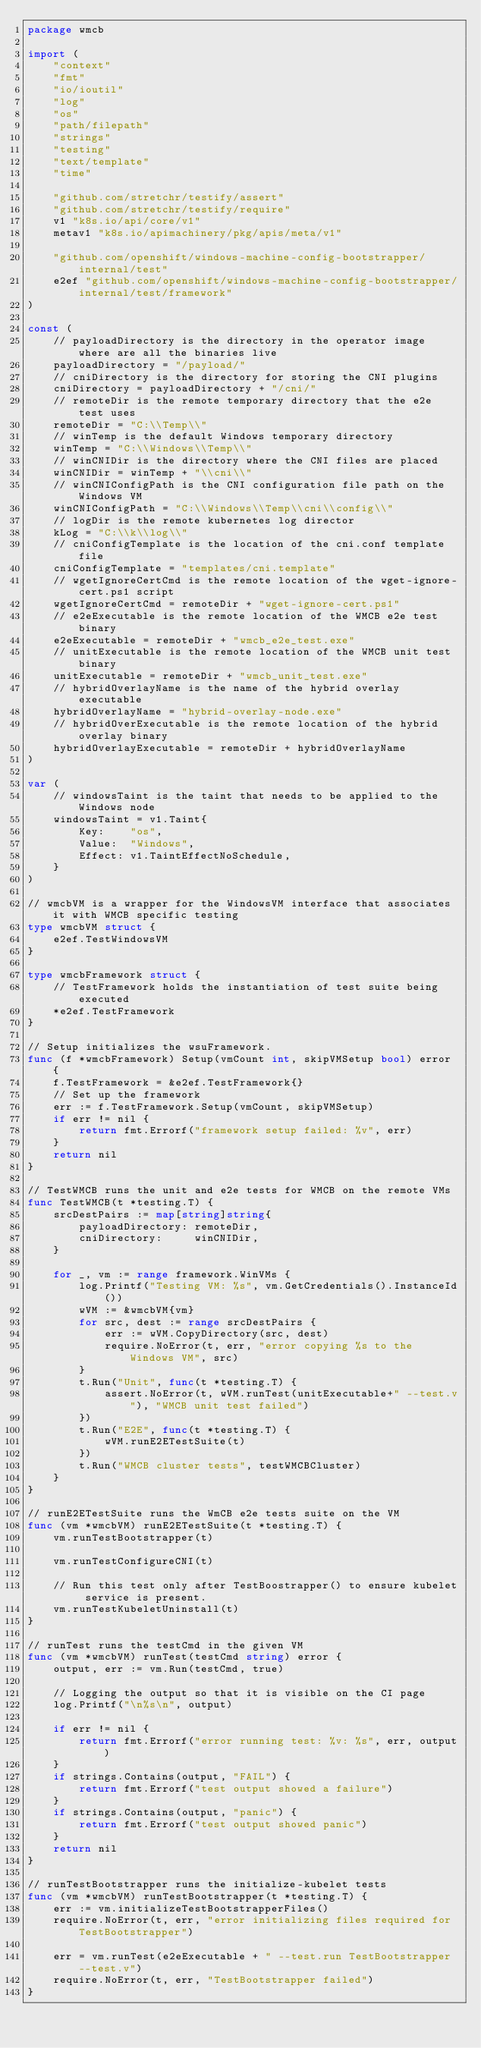<code> <loc_0><loc_0><loc_500><loc_500><_Go_>package wmcb

import (
	"context"
	"fmt"
	"io/ioutil"
	"log"
	"os"
	"path/filepath"
	"strings"
	"testing"
	"text/template"
	"time"

	"github.com/stretchr/testify/assert"
	"github.com/stretchr/testify/require"
	v1 "k8s.io/api/core/v1"
	metav1 "k8s.io/apimachinery/pkg/apis/meta/v1"

	"github.com/openshift/windows-machine-config-bootstrapper/internal/test"
	e2ef "github.com/openshift/windows-machine-config-bootstrapper/internal/test/framework"
)

const (
	// payloadDirectory is the directory in the operator image where are all the binaries live
	payloadDirectory = "/payload/"
	// cniDirectory is the directory for storing the CNI plugins
	cniDirectory = payloadDirectory + "/cni/"
	// remoteDir is the remote temporary directory that the e2e test uses
	remoteDir = "C:\\Temp\\"
	// winTemp is the default Windows temporary directory
	winTemp = "C:\\Windows\\Temp\\"
	// winCNIDir is the directory where the CNI files are placed
	winCNIDir = winTemp + "\\cni\\"
	// winCNIConfigPath is the CNI configuration file path on the Windows VM
	winCNIConfigPath = "C:\\Windows\\Temp\\cni\\config\\"
	// logDir is the remote kubernetes log director
	kLog = "C:\\k\\log\\"
	// cniConfigTemplate is the location of the cni.conf template file
	cniConfigTemplate = "templates/cni.template"
	// wgetIgnoreCertCmd is the remote location of the wget-ignore-cert.ps1 script
	wgetIgnoreCertCmd = remoteDir + "wget-ignore-cert.ps1"
	// e2eExecutable is the remote location of the WMCB e2e test binary
	e2eExecutable = remoteDir + "wmcb_e2e_test.exe"
	// unitExecutable is the remote location of the WMCB unit test binary
	unitExecutable = remoteDir + "wmcb_unit_test.exe"
	// hybridOverlayName is the name of the hybrid overlay executable
	hybridOverlayName = "hybrid-overlay-node.exe"
	// hybridOverExecutable is the remote location of the hybrid overlay binary
	hybridOverlayExecutable = remoteDir + hybridOverlayName
)

var (
	// windowsTaint is the taint that needs to be applied to the Windows node
	windowsTaint = v1.Taint{
		Key:    "os",
		Value:  "Windows",
		Effect: v1.TaintEffectNoSchedule,
	}
)

// wmcbVM is a wrapper for the WindowsVM interface that associates it with WMCB specific testing
type wmcbVM struct {
	e2ef.TestWindowsVM
}

type wmcbFramework struct {
	// TestFramework holds the instantiation of test suite being executed
	*e2ef.TestFramework
}

// Setup initializes the wsuFramework.
func (f *wmcbFramework) Setup(vmCount int, skipVMSetup bool) error {
	f.TestFramework = &e2ef.TestFramework{}
	// Set up the framework
	err := f.TestFramework.Setup(vmCount, skipVMSetup)
	if err != nil {
		return fmt.Errorf("framework setup failed: %v", err)
	}
	return nil
}

// TestWMCB runs the unit and e2e tests for WMCB on the remote VMs
func TestWMCB(t *testing.T) {
	srcDestPairs := map[string]string{
		payloadDirectory: remoteDir,
		cniDirectory:     winCNIDir,
	}

	for _, vm := range framework.WinVMs {
		log.Printf("Testing VM: %s", vm.GetCredentials().InstanceId())
		wVM := &wmcbVM{vm}
		for src, dest := range srcDestPairs {
			err := wVM.CopyDirectory(src, dest)
			require.NoError(t, err, "error copying %s to the Windows VM", src)
		}
		t.Run("Unit", func(t *testing.T) {
			assert.NoError(t, wVM.runTest(unitExecutable+" --test.v"), "WMCB unit test failed")
		})
		t.Run("E2E", func(t *testing.T) {
			wVM.runE2ETestSuite(t)
		})
		t.Run("WMCB cluster tests", testWMCBCluster)
	}
}

// runE2ETestSuite runs the WmCB e2e tests suite on the VM
func (vm *wmcbVM) runE2ETestSuite(t *testing.T) {
	vm.runTestBootstrapper(t)

	vm.runTestConfigureCNI(t)

	// Run this test only after TestBoostrapper() to ensure kubelet service is present.
	vm.runTestKubeletUninstall(t)
}

// runTest runs the testCmd in the given VM
func (vm *wmcbVM) runTest(testCmd string) error {
	output, err := vm.Run(testCmd, true)

	// Logging the output so that it is visible on the CI page
	log.Printf("\n%s\n", output)

	if err != nil {
		return fmt.Errorf("error running test: %v: %s", err, output)
	}
	if strings.Contains(output, "FAIL") {
		return fmt.Errorf("test output showed a failure")
	}
	if strings.Contains(output, "panic") {
		return fmt.Errorf("test output showed panic")
	}
	return nil
}

// runTestBootstrapper runs the initialize-kubelet tests
func (vm *wmcbVM) runTestBootstrapper(t *testing.T) {
	err := vm.initializeTestBootstrapperFiles()
	require.NoError(t, err, "error initializing files required for TestBootstrapper")

	err = vm.runTest(e2eExecutable + " --test.run TestBootstrapper --test.v")
	require.NoError(t, err, "TestBootstrapper failed")
}
</code> 